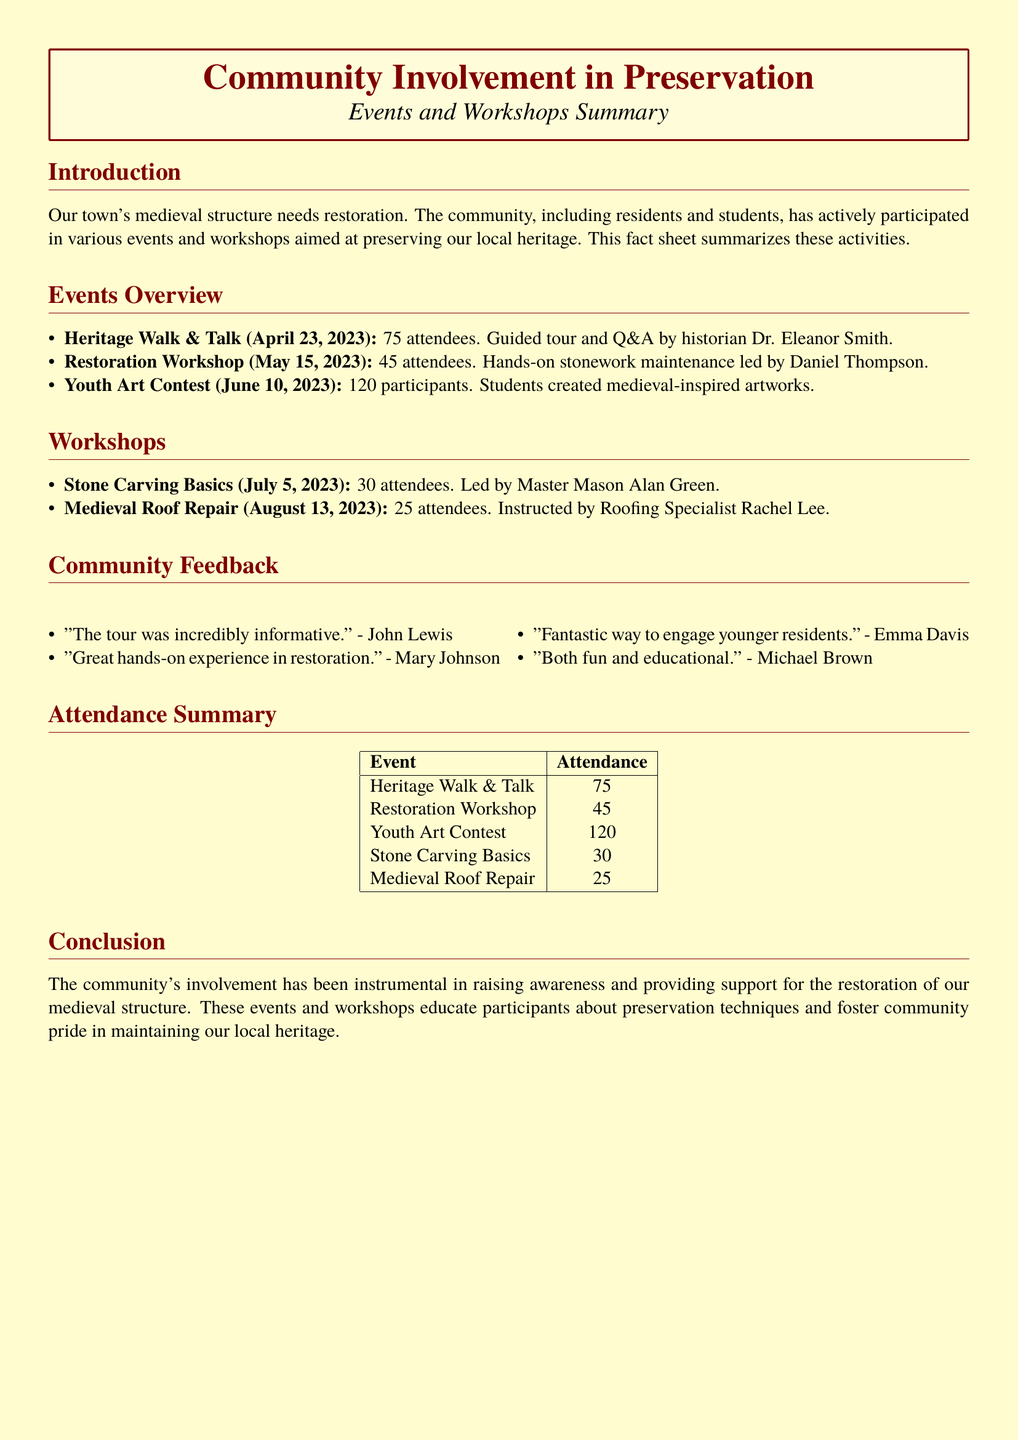What date was the Heritage Walk & Talk held? The Heritage Walk & Talk is listed with its date in the document, which is April 23, 2023.
Answer: April 23, 2023 How many attendees participated in the Youth Art Contest? The Youth Art Contest attendance is directly stated in the document as 120 participants.
Answer: 120 participants Who led the Restoration Workshop? The document names Daniel Thompson as the leader of the Restoration Workshop.
Answer: Daniel Thompson What is one piece of feedback from a participant? Participant feedback is included in the document, for example, "Both fun and educational." by Michael Brown.
Answer: "Both fun and educational." How many total events are mentioned in the document? The document lists five distinct events related to community involvement in preservation.
Answer: 5 What was the total attendance for all events combined? The total attendance can be calculated by adding 75, 45, 120, 30, and 25 attendees, which sums up to 295.
Answer: 295 What is the primary goal of the events and workshops? The document states that the main purpose is to raise awareness and support the restoration of the medieval structure.
Answer: Support restoration Who was the instructor for the Medieval Roof Repair workshop? The document provides the name of the instructor for the Medieval Roof Repair workshop, which is Rachel Lee.
Answer: Rachel Lee What type of event was held on June 10, 2023? The document specifies that June 10, 2023, was the date of the Youth Art Contest.
Answer: Youth Art Contest 